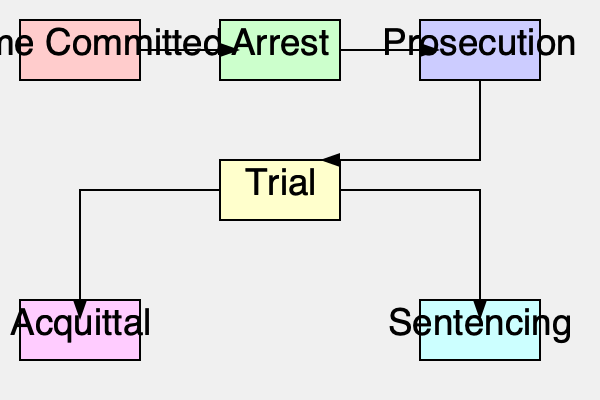In the flowchart depicting the criminal justice system, which stage immediately precedes the "Sentencing" phase, and what critical decision point determines whether an individual proceeds to sentencing or takes an alternative path? To answer this question, we need to analyze the flowchart step-by-step:

1. The flowchart begins with "Crime Committed," which leads to "Arrest."

2. After "Arrest," the next stage is "Prosecution."

3. From "Prosecution," the flow moves to "Trial."

4. The "Trial" stage is the critical decision point in this flowchart. It has two possible outcomes:
   a) A path leading to "Acquittal"
   b) A path leading to "Sentencing"

5. The "Trial" stage immediately precedes both "Acquittal" and "Sentencing."

6. The critical decision that determines whether an individual proceeds to sentencing or takes the alternative path (acquittal) is the verdict of the trial.

7. If the verdict is "guilty," the individual proceeds to "Sentencing."
   If the verdict is "not guilty," the individual follows the path to "Acquittal."

Therefore, the stage immediately preceding "Sentencing" is "Trial," and the critical decision point is the trial verdict (guilty or not guilty).
Answer: Trial; verdict (guilty/not guilty) 